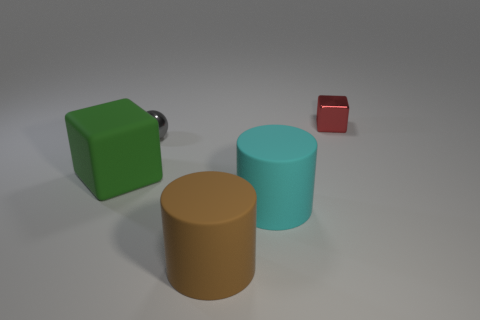Add 5 big purple matte cylinders. How many objects exist? 10 Subtract all cylinders. How many objects are left? 3 Subtract 0 yellow cubes. How many objects are left? 5 Subtract all small metal cubes. Subtract all big yellow metal objects. How many objects are left? 4 Add 3 green things. How many green things are left? 4 Add 4 large yellow rubber cylinders. How many large yellow rubber cylinders exist? 4 